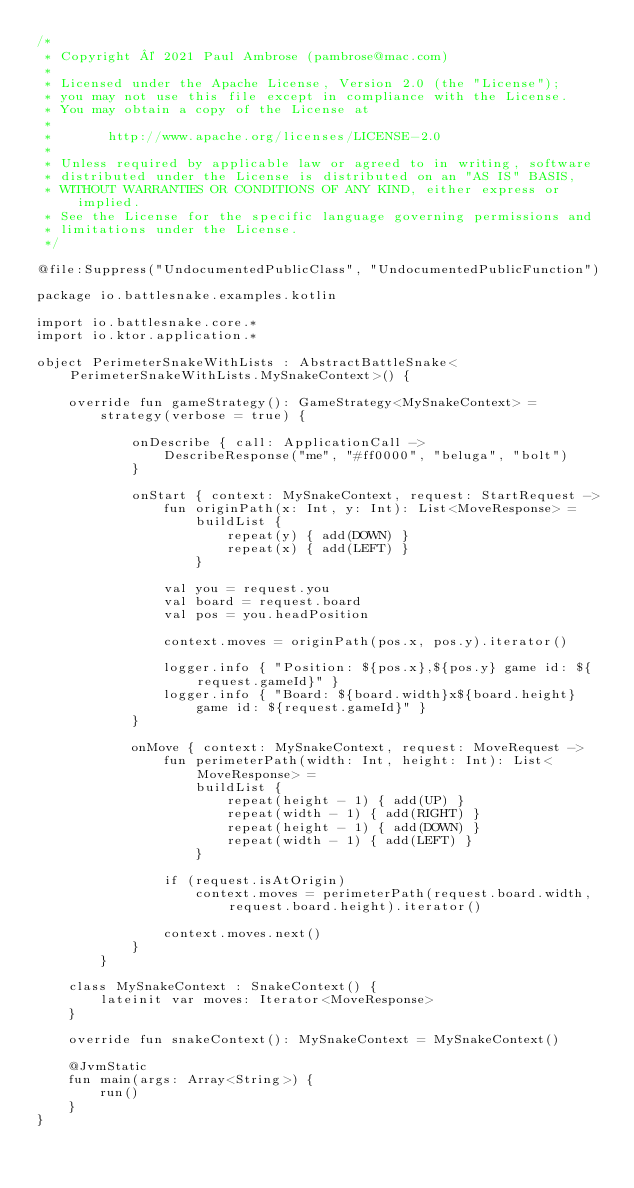<code> <loc_0><loc_0><loc_500><loc_500><_Kotlin_>/*
 * Copyright © 2021 Paul Ambrose (pambrose@mac.com)
 *
 * Licensed under the Apache License, Version 2.0 (the "License");
 * you may not use this file except in compliance with the License.
 * You may obtain a copy of the License at
 *
 *       http://www.apache.org/licenses/LICENSE-2.0
 *
 * Unless required by applicable law or agreed to in writing, software
 * distributed under the License is distributed on an "AS IS" BASIS,
 * WITHOUT WARRANTIES OR CONDITIONS OF ANY KIND, either express or implied.
 * See the License for the specific language governing permissions and
 * limitations under the License.
 */

@file:Suppress("UndocumentedPublicClass", "UndocumentedPublicFunction")

package io.battlesnake.examples.kotlin

import io.battlesnake.core.*
import io.ktor.application.*

object PerimeterSnakeWithLists : AbstractBattleSnake<PerimeterSnakeWithLists.MySnakeContext>() {

    override fun gameStrategy(): GameStrategy<MySnakeContext> =
        strategy(verbose = true) {

            onDescribe { call: ApplicationCall ->
                DescribeResponse("me", "#ff0000", "beluga", "bolt")
            }

            onStart { context: MySnakeContext, request: StartRequest ->
                fun originPath(x: Int, y: Int): List<MoveResponse> =
                    buildList {
                        repeat(y) { add(DOWN) }
                        repeat(x) { add(LEFT) }
                    }

                val you = request.you
                val board = request.board
                val pos = you.headPosition

                context.moves = originPath(pos.x, pos.y).iterator()

                logger.info { "Position: ${pos.x},${pos.y} game id: ${request.gameId}" }
                logger.info { "Board: ${board.width}x${board.height} game id: ${request.gameId}" }
            }

            onMove { context: MySnakeContext, request: MoveRequest ->
                fun perimeterPath(width: Int, height: Int): List<MoveResponse> =
                    buildList {
                        repeat(height - 1) { add(UP) }
                        repeat(width - 1) { add(RIGHT) }
                        repeat(height - 1) { add(DOWN) }
                        repeat(width - 1) { add(LEFT) }
                    }

                if (request.isAtOrigin)
                    context.moves = perimeterPath(request.board.width, request.board.height).iterator()

                context.moves.next()
            }
        }

    class MySnakeContext : SnakeContext() {
        lateinit var moves: Iterator<MoveResponse>
    }

    override fun snakeContext(): MySnakeContext = MySnakeContext()

    @JvmStatic
    fun main(args: Array<String>) {
        run()
    }
}</code> 